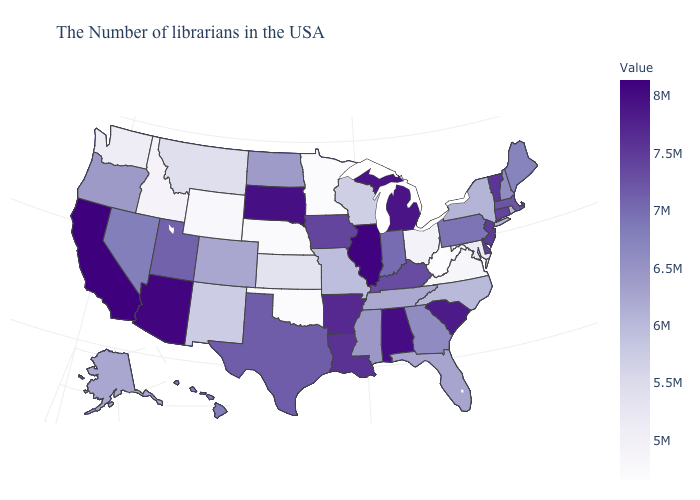Among the states that border Idaho , does Montana have the lowest value?
Quick response, please. No. Among the states that border Wyoming , does South Dakota have the highest value?
Be succinct. Yes. Among the states that border North Dakota , does South Dakota have the lowest value?
Keep it brief. No. Does West Virginia have the lowest value in the USA?
Write a very short answer. Yes. Does the map have missing data?
Write a very short answer. No. 